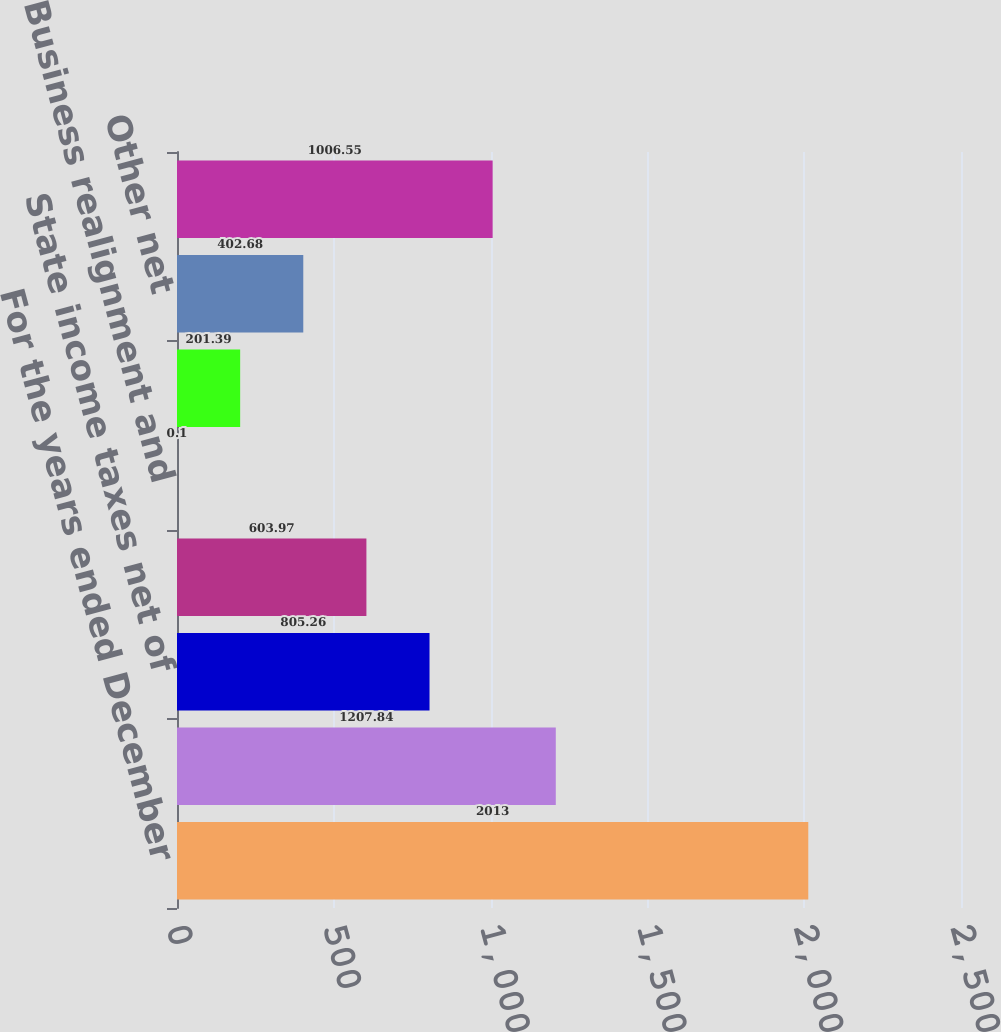Convert chart to OTSL. <chart><loc_0><loc_0><loc_500><loc_500><bar_chart><fcel>For the years ended December<fcel>Federal statutory income tax<fcel>State income taxes net of<fcel>Qualified production income<fcel>Business realignment and<fcel>International operations<fcel>Other net<fcel>Effective income tax rate<nl><fcel>2013<fcel>1207.84<fcel>805.26<fcel>603.97<fcel>0.1<fcel>201.39<fcel>402.68<fcel>1006.55<nl></chart> 